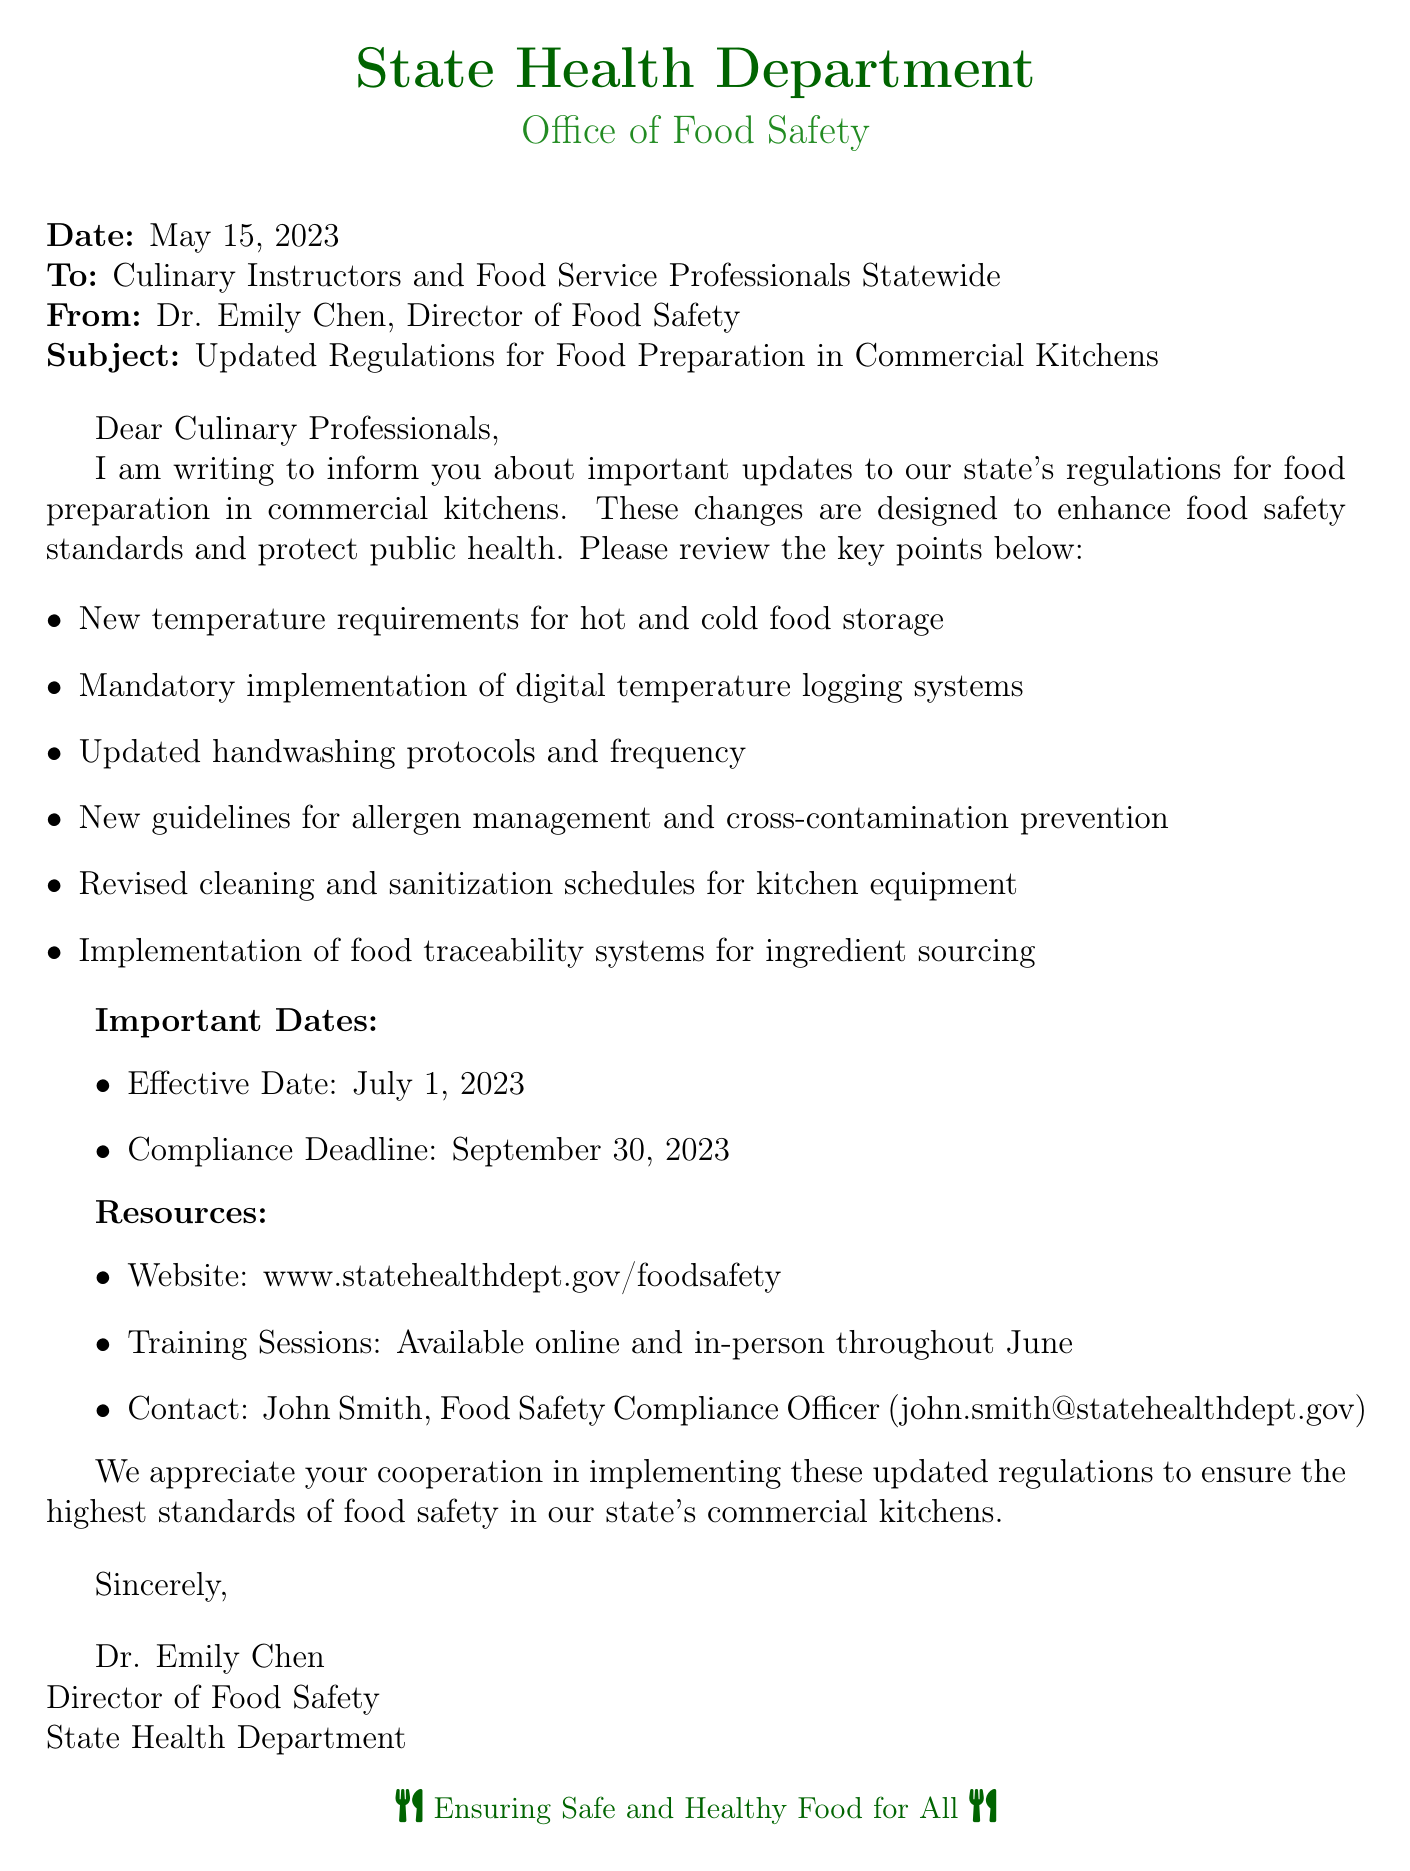What is the name of the sender? The sender's name is mentioned in the document as Dr. Emily Chen.
Answer: Dr. Emily Chen What is the effective date of the new regulations? The document specifies that the effective date for the new regulations is July 1, 2023.
Answer: July 1, 2023 Who is the contact person for food safety compliance? The document identifies John Smith as the contact person for food safety compliance.
Answer: John Smith What protocol has been updated regarding handwashing? The document states that the handwashing protocols and frequency have been updated.
Answer: Updated handwashing protocols and frequency When is the compliance deadline for the new regulations? The document indicates that the compliance deadline is September 30, 2023.
Answer: September 30, 2023 What is the website provided for more resources? The document includes the website www.statehealthdept.gov/foodsafety for additional resources.
Answer: www.statehealthdept.gov/foodsafety What type of systems must be implemented according to the new regulations? The document notes the mandatory implementation of digital temperature logging systems.
Answer: Digital temperature logging systems What are the new guidelines focusing on to prevent food safety issues? The document outlines new guidelines for allergen management and cross-contamination prevention.
Answer: Allergen management and cross-contamination prevention What is the title of the sender? The title of the sender in the document is Director of Food Safety.
Answer: Director of Food Safety 